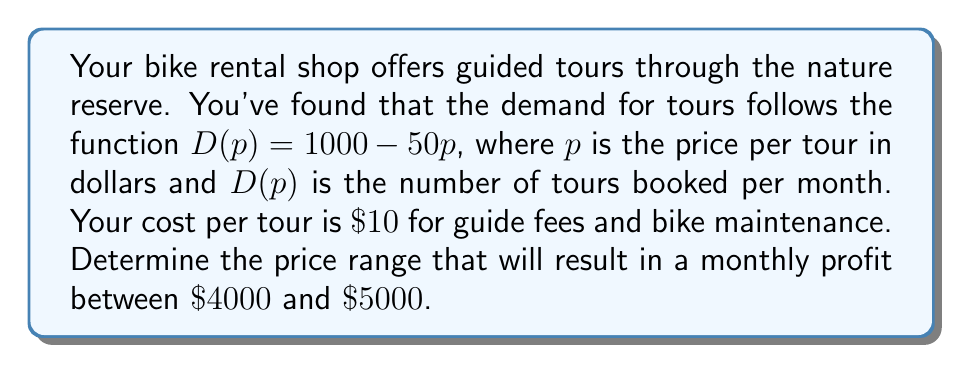Can you solve this math problem? Let's approach this step-by-step:

1) First, let's define our profit function. Profit is revenue minus cost:
   $P(p) = pD(p) - 10D(p)$
   
2) Substitute the demand function:
   $P(p) = p(1000 - 50p) - 10(1000 - 50p)$
   
3) Expand this:
   $P(p) = 1000p - 50p^2 - 10000 + 500p$
   $P(p) = 1500p - 50p^2 - 10000$
   
4) We want to find $p$ where $4000 \leq P(p) \leq 5000$. Let's set up these inequalities:

   $4000 \leq 1500p - 50p^2 - 10000 \leq 5000$
   
5) Add 10000 to all parts:
   $14000 \leq 1500p - 50p^2 \leq 15000$
   
6) Divide all parts by 50:
   $280 \leq 30p - p^2 \leq 300$
   
7) Rearrange to standard quadratic form:
   $p^2 - 30p + 280 \leq 0$ and $p^2 - 30p + 300 \geq 0$
   
8) Solve these quadratic inequalities:
   For $p^2 - 30p + 280 \leq 0$:
   $(p - 10)(p - 20) \leq 0$, so $10 \leq p \leq 20$
   
   For $p^2 - 30p + 300 \geq 0$:
   $(p - 15)^2 \geq 75$, so $p \leq 15 - \sqrt{75}$ or $p \geq 15 + \sqrt{75}$
   
9) Combining these results and considering that price must be positive:
   $15 - \sqrt{75} \leq p \leq 15 + \sqrt{75}$ and $10 \leq p \leq 20$
   
10) Simplify:
    $10 \leq p \leq 15 + \sqrt{75}$ (approximately $10 \leq p \leq 23.66$)
Answer: $[10, 15 + \sqrt{75}]$ or approximately $[10, 23.66]$ 